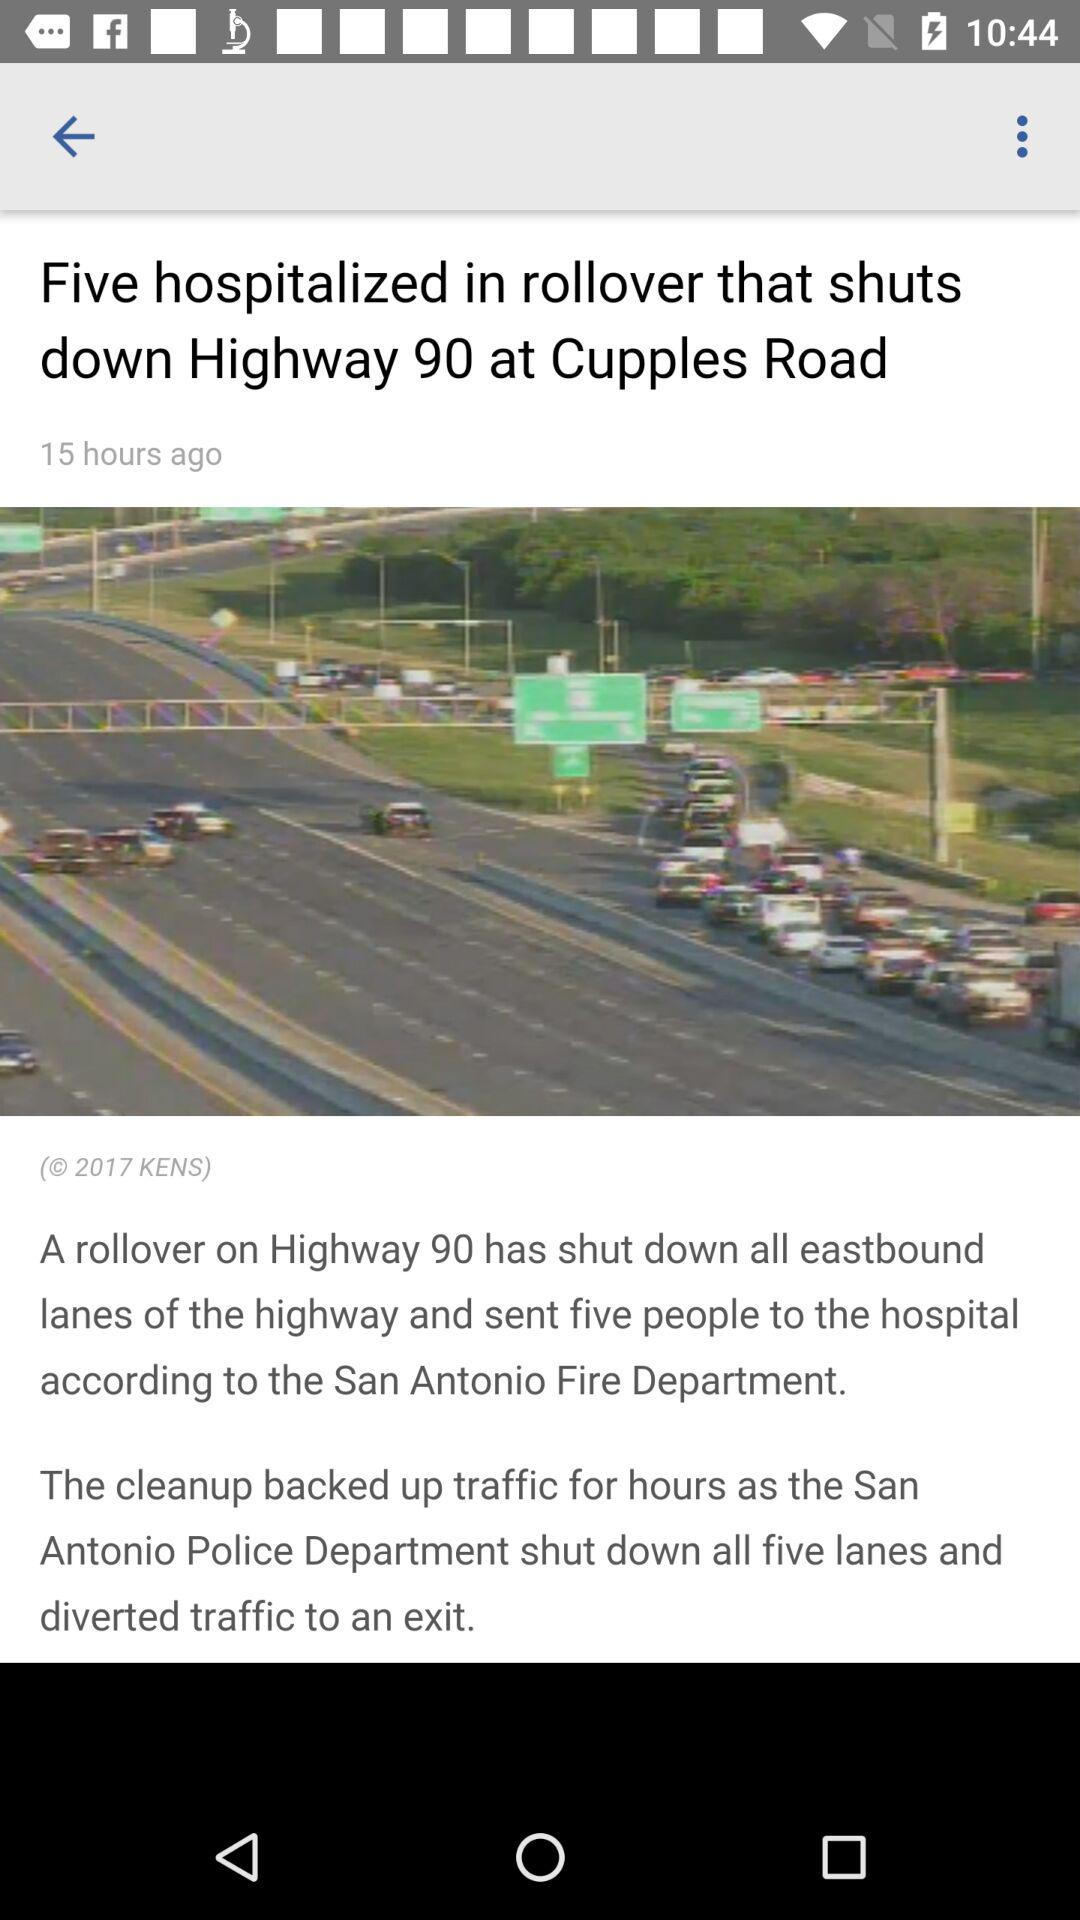When did the news come? The news came 15 hours ago. 